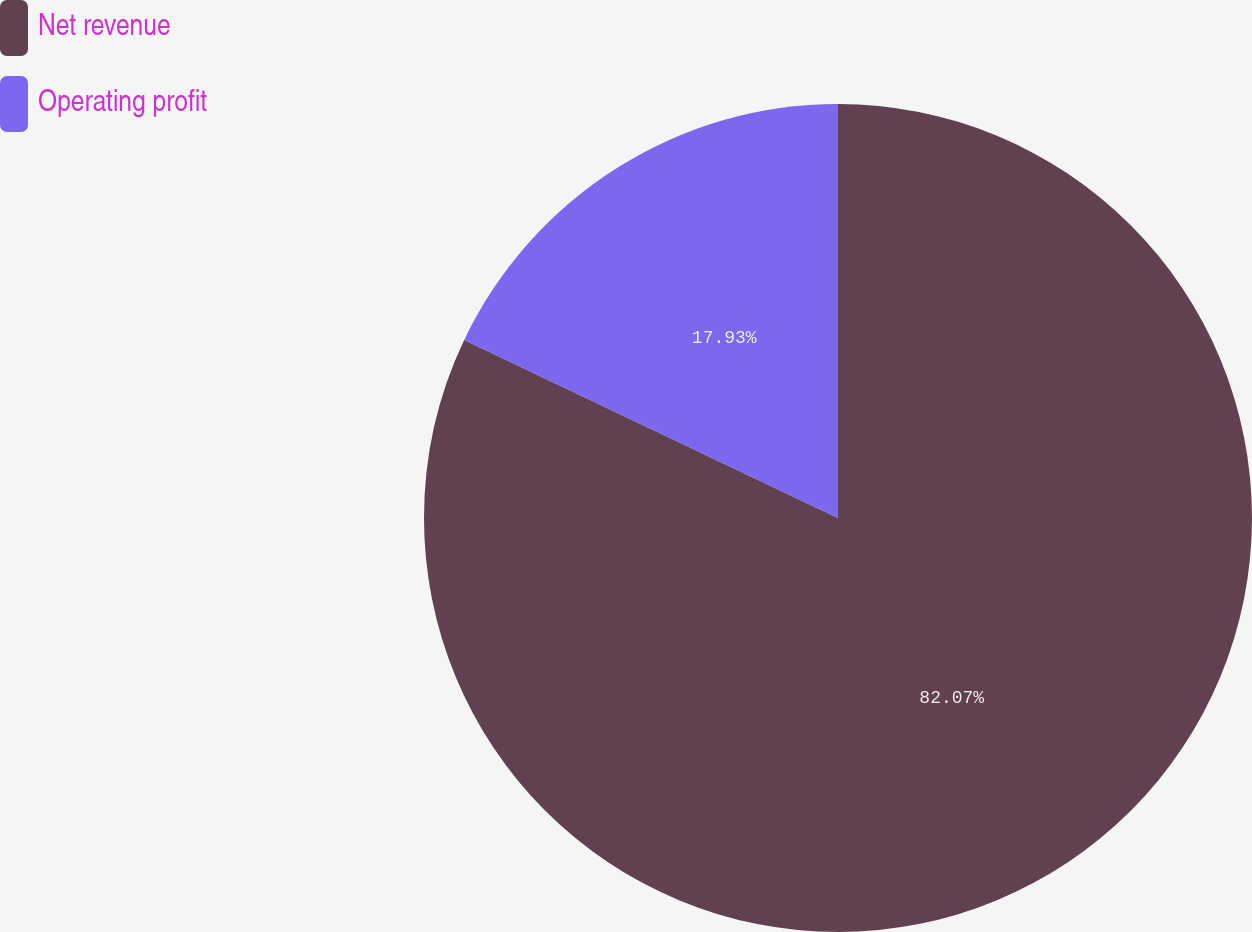Convert chart. <chart><loc_0><loc_0><loc_500><loc_500><pie_chart><fcel>Net revenue<fcel>Operating profit<nl><fcel>82.07%<fcel>17.93%<nl></chart> 